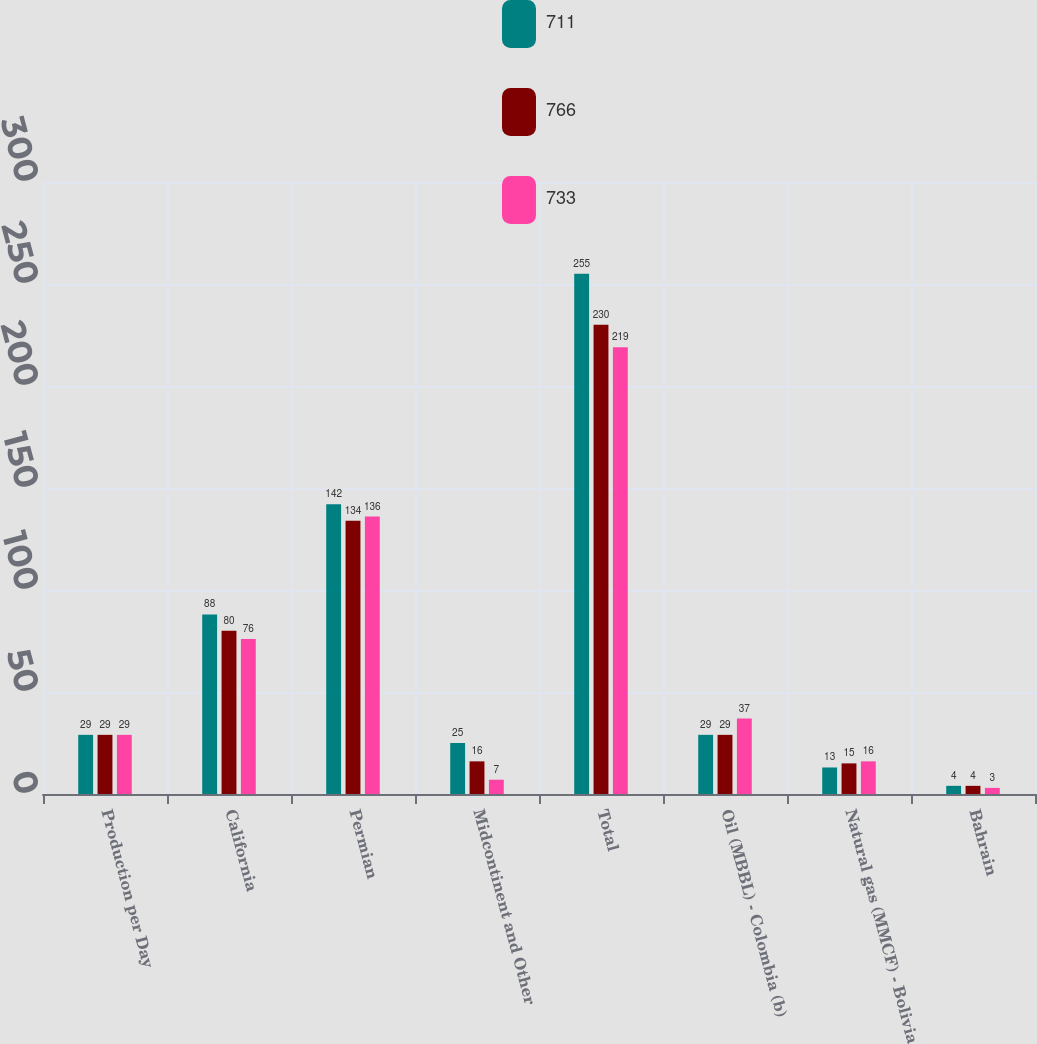Convert chart to OTSL. <chart><loc_0><loc_0><loc_500><loc_500><stacked_bar_chart><ecel><fcel>Production per Day<fcel>California<fcel>Permian<fcel>Midcontinent and Other<fcel>Total<fcel>Oil (MBBL) - Colombia (b)<fcel>Natural gas (MMCF) - Bolivia<fcel>Bahrain<nl><fcel>711<fcel>29<fcel>88<fcel>142<fcel>25<fcel>255<fcel>29<fcel>13<fcel>4<nl><fcel>766<fcel>29<fcel>80<fcel>134<fcel>16<fcel>230<fcel>29<fcel>15<fcel>4<nl><fcel>733<fcel>29<fcel>76<fcel>136<fcel>7<fcel>219<fcel>37<fcel>16<fcel>3<nl></chart> 